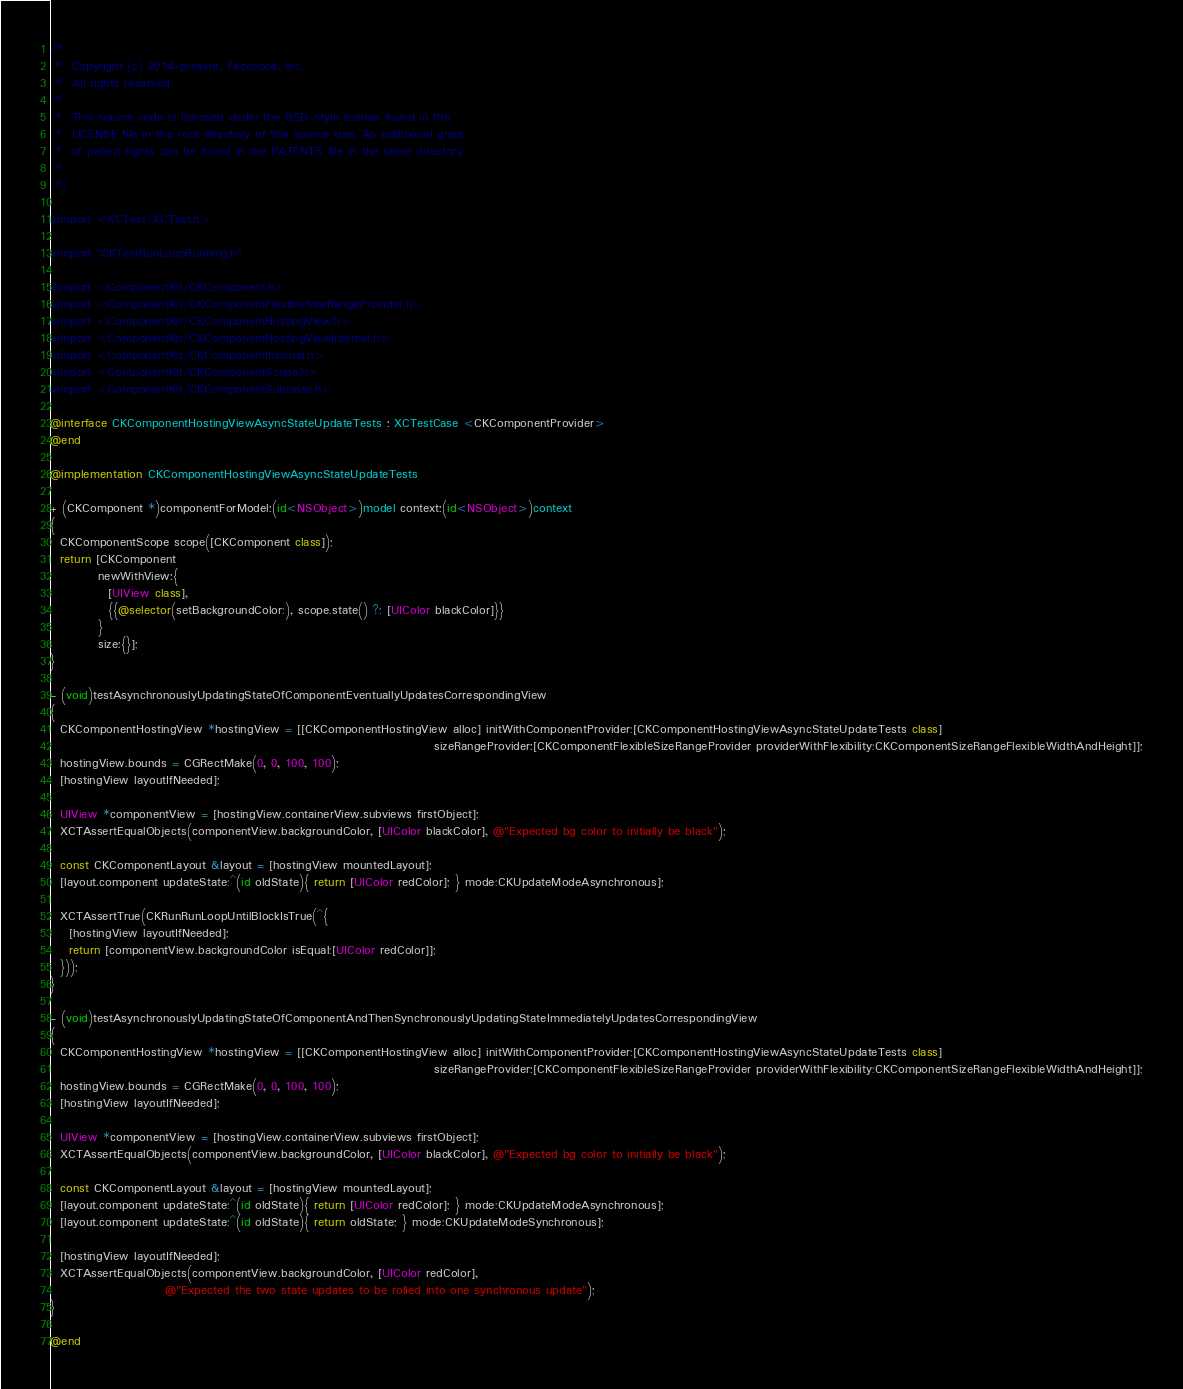Convert code to text. <code><loc_0><loc_0><loc_500><loc_500><_ObjectiveC_>/*
 *  Copyright (c) 2014-present, Facebook, Inc.
 *  All rights reserved.
 *
 *  This source code is licensed under the BSD-style license found in the
 *  LICENSE file in the root directory of this source tree. An additional grant
 *  of patent rights can be found in the PATENTS file in the same directory.
 *
 */

#import <XCTest/XCTest.h>

#import "CKTestRunLoopRunning.h"

#import <ComponentKit/CKComponent.h>
#import <ComponentKit/CKComponentFlexibleSizeRangeProvider.h>
#import <ComponentKit/CKComponentHostingView.h>
#import <ComponentKit/CKComponentHostingViewInternal.h>
#import <ComponentKit/CKComponentInternal.h>
#import <ComponentKit/CKComponentScope.h>
#import <ComponentKit/CKComponentSubclass.h>

@interface CKComponentHostingViewAsyncStateUpdateTests : XCTestCase <CKComponentProvider>
@end

@implementation CKComponentHostingViewAsyncStateUpdateTests

+ (CKComponent *)componentForModel:(id<NSObject>)model context:(id<NSObject>)context
{
  CKComponentScope scope([CKComponent class]);
  return [CKComponent
          newWithView:{
            [UIView class],
            {{@selector(setBackgroundColor:), scope.state() ?: [UIColor blackColor]}}
          }
          size:{}];
}

- (void)testAsynchronouslyUpdatingStateOfComponentEventuallyUpdatesCorrespondingView
{
  CKComponentHostingView *hostingView = [[CKComponentHostingView alloc] initWithComponentProvider:[CKComponentHostingViewAsyncStateUpdateTests class]
                                                                                sizeRangeProvider:[CKComponentFlexibleSizeRangeProvider providerWithFlexibility:CKComponentSizeRangeFlexibleWidthAndHeight]];
  hostingView.bounds = CGRectMake(0, 0, 100, 100);
  [hostingView layoutIfNeeded];

  UIView *componentView = [hostingView.containerView.subviews firstObject];
  XCTAssertEqualObjects(componentView.backgroundColor, [UIColor blackColor], @"Expected bg color to initially be black");

  const CKComponentLayout &layout = [hostingView mountedLayout];
  [layout.component updateState:^(id oldState){ return [UIColor redColor]; } mode:CKUpdateModeAsynchronous];

  XCTAssertTrue(CKRunRunLoopUntilBlockIsTrue(^{
    [hostingView layoutIfNeeded];
    return [componentView.backgroundColor isEqual:[UIColor redColor]];
  }));
}

- (void)testAsynchronouslyUpdatingStateOfComponentAndThenSynchronouslyUpdatingStateImmediatelyUpdatesCorrespondingView
{
  CKComponentHostingView *hostingView = [[CKComponentHostingView alloc] initWithComponentProvider:[CKComponentHostingViewAsyncStateUpdateTests class]
                                                                                sizeRangeProvider:[CKComponentFlexibleSizeRangeProvider providerWithFlexibility:CKComponentSizeRangeFlexibleWidthAndHeight]];
  hostingView.bounds = CGRectMake(0, 0, 100, 100);
  [hostingView layoutIfNeeded];

  UIView *componentView = [hostingView.containerView.subviews firstObject];
  XCTAssertEqualObjects(componentView.backgroundColor, [UIColor blackColor], @"Expected bg color to initially be black");

  const CKComponentLayout &layout = [hostingView mountedLayout];
  [layout.component updateState:^(id oldState){ return [UIColor redColor]; } mode:CKUpdateModeAsynchronous];
  [layout.component updateState:^(id oldState){ return oldState; } mode:CKUpdateModeSynchronous];

  [hostingView layoutIfNeeded];
  XCTAssertEqualObjects(componentView.backgroundColor, [UIColor redColor],
                        @"Expected the two state updates to be rolled into one synchronous update");
}

@end
</code> 